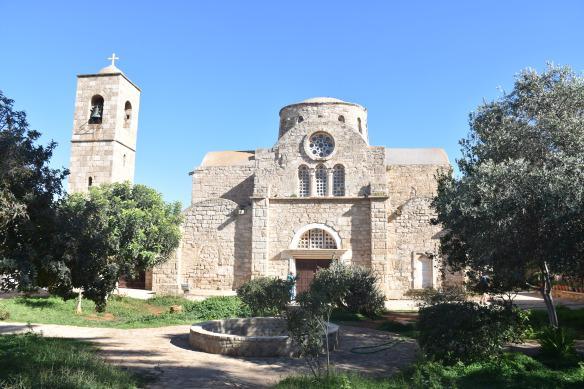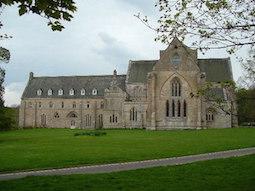The first image is the image on the left, the second image is the image on the right. For the images shown, is this caption "One building features three arches topped by a circle over the main archway entrance." true? Answer yes or no. Yes. The first image is the image on the left, the second image is the image on the right. Considering the images on both sides, is "There are three windows on above the main door of a cathedral." valid? Answer yes or no. Yes. 